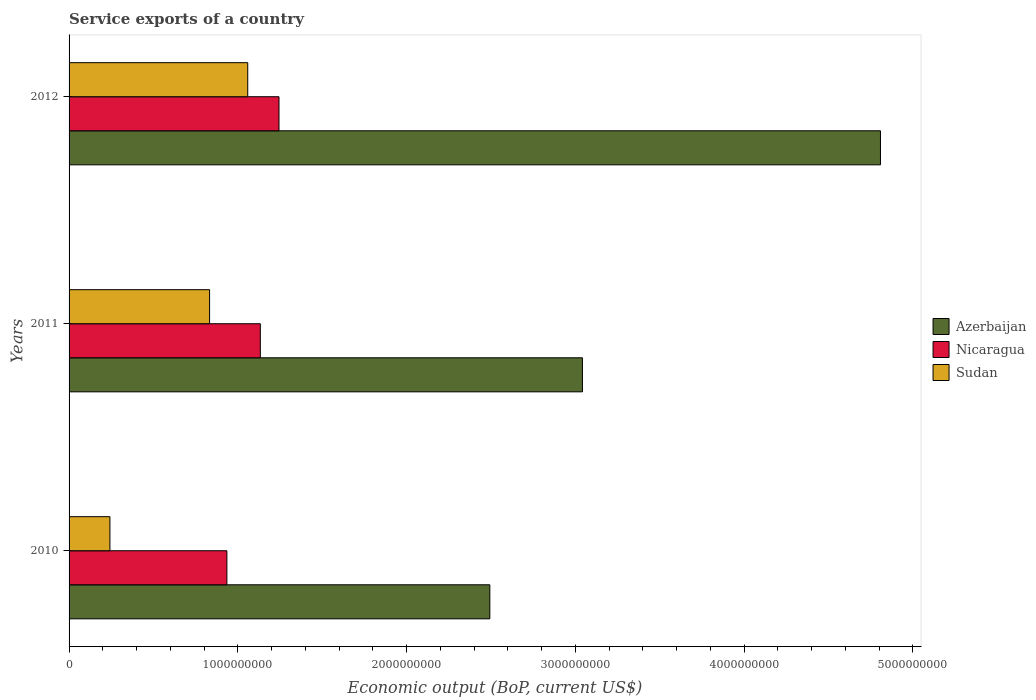How many groups of bars are there?
Provide a succinct answer. 3. Are the number of bars per tick equal to the number of legend labels?
Your response must be concise. Yes. Are the number of bars on each tick of the Y-axis equal?
Your answer should be very brief. Yes. How many bars are there on the 2nd tick from the top?
Give a very brief answer. 3. What is the service exports in Azerbaijan in 2012?
Provide a succinct answer. 4.81e+09. Across all years, what is the maximum service exports in Sudan?
Give a very brief answer. 1.06e+09. Across all years, what is the minimum service exports in Azerbaijan?
Ensure brevity in your answer.  2.49e+09. In which year was the service exports in Sudan maximum?
Your answer should be compact. 2012. In which year was the service exports in Azerbaijan minimum?
Offer a very short reply. 2010. What is the total service exports in Sudan in the graph?
Keep it short and to the point. 2.13e+09. What is the difference between the service exports in Nicaragua in 2010 and that in 2012?
Provide a short and direct response. -3.09e+08. What is the difference between the service exports in Azerbaijan in 2010 and the service exports in Nicaragua in 2012?
Your answer should be very brief. 1.25e+09. What is the average service exports in Azerbaijan per year?
Keep it short and to the point. 3.45e+09. In the year 2012, what is the difference between the service exports in Azerbaijan and service exports in Nicaragua?
Offer a terse response. 3.56e+09. What is the ratio of the service exports in Azerbaijan in 2011 to that in 2012?
Offer a terse response. 0.63. Is the difference between the service exports in Azerbaijan in 2011 and 2012 greater than the difference between the service exports in Nicaragua in 2011 and 2012?
Offer a terse response. No. What is the difference between the highest and the second highest service exports in Azerbaijan?
Make the answer very short. 1.77e+09. What is the difference between the highest and the lowest service exports in Sudan?
Offer a very short reply. 8.17e+08. In how many years, is the service exports in Sudan greater than the average service exports in Sudan taken over all years?
Your answer should be compact. 2. What does the 1st bar from the top in 2012 represents?
Make the answer very short. Sudan. What does the 2nd bar from the bottom in 2011 represents?
Ensure brevity in your answer.  Nicaragua. Are all the bars in the graph horizontal?
Make the answer very short. Yes. What is the difference between two consecutive major ticks on the X-axis?
Offer a terse response. 1.00e+09. Where does the legend appear in the graph?
Offer a very short reply. Center right. How are the legend labels stacked?
Offer a very short reply. Vertical. What is the title of the graph?
Your response must be concise. Service exports of a country. What is the label or title of the X-axis?
Your answer should be very brief. Economic output (BoP, current US$). What is the label or title of the Y-axis?
Keep it short and to the point. Years. What is the Economic output (BoP, current US$) in Azerbaijan in 2010?
Offer a terse response. 2.49e+09. What is the Economic output (BoP, current US$) of Nicaragua in 2010?
Provide a short and direct response. 9.35e+08. What is the Economic output (BoP, current US$) of Sudan in 2010?
Your response must be concise. 2.42e+08. What is the Economic output (BoP, current US$) in Azerbaijan in 2011?
Provide a succinct answer. 3.04e+09. What is the Economic output (BoP, current US$) in Nicaragua in 2011?
Offer a terse response. 1.13e+09. What is the Economic output (BoP, current US$) of Sudan in 2011?
Your answer should be compact. 8.33e+08. What is the Economic output (BoP, current US$) of Azerbaijan in 2012?
Offer a very short reply. 4.81e+09. What is the Economic output (BoP, current US$) of Nicaragua in 2012?
Keep it short and to the point. 1.24e+09. What is the Economic output (BoP, current US$) in Sudan in 2012?
Your answer should be compact. 1.06e+09. Across all years, what is the maximum Economic output (BoP, current US$) in Azerbaijan?
Offer a terse response. 4.81e+09. Across all years, what is the maximum Economic output (BoP, current US$) of Nicaragua?
Provide a short and direct response. 1.24e+09. Across all years, what is the maximum Economic output (BoP, current US$) of Sudan?
Your response must be concise. 1.06e+09. Across all years, what is the minimum Economic output (BoP, current US$) in Azerbaijan?
Ensure brevity in your answer.  2.49e+09. Across all years, what is the minimum Economic output (BoP, current US$) of Nicaragua?
Give a very brief answer. 9.35e+08. Across all years, what is the minimum Economic output (BoP, current US$) of Sudan?
Keep it short and to the point. 2.42e+08. What is the total Economic output (BoP, current US$) in Azerbaijan in the graph?
Make the answer very short. 1.03e+1. What is the total Economic output (BoP, current US$) of Nicaragua in the graph?
Offer a very short reply. 3.31e+09. What is the total Economic output (BoP, current US$) in Sudan in the graph?
Provide a succinct answer. 2.13e+09. What is the difference between the Economic output (BoP, current US$) of Azerbaijan in 2010 and that in 2011?
Provide a short and direct response. -5.49e+08. What is the difference between the Economic output (BoP, current US$) in Nicaragua in 2010 and that in 2011?
Give a very brief answer. -1.98e+08. What is the difference between the Economic output (BoP, current US$) of Sudan in 2010 and that in 2011?
Offer a terse response. -5.91e+08. What is the difference between the Economic output (BoP, current US$) of Azerbaijan in 2010 and that in 2012?
Ensure brevity in your answer.  -2.32e+09. What is the difference between the Economic output (BoP, current US$) of Nicaragua in 2010 and that in 2012?
Your response must be concise. -3.09e+08. What is the difference between the Economic output (BoP, current US$) in Sudan in 2010 and that in 2012?
Your answer should be very brief. -8.17e+08. What is the difference between the Economic output (BoP, current US$) of Azerbaijan in 2011 and that in 2012?
Provide a short and direct response. -1.77e+09. What is the difference between the Economic output (BoP, current US$) in Nicaragua in 2011 and that in 2012?
Offer a very short reply. -1.11e+08. What is the difference between the Economic output (BoP, current US$) of Sudan in 2011 and that in 2012?
Offer a terse response. -2.26e+08. What is the difference between the Economic output (BoP, current US$) of Azerbaijan in 2010 and the Economic output (BoP, current US$) of Nicaragua in 2011?
Give a very brief answer. 1.36e+09. What is the difference between the Economic output (BoP, current US$) in Azerbaijan in 2010 and the Economic output (BoP, current US$) in Sudan in 2011?
Your response must be concise. 1.66e+09. What is the difference between the Economic output (BoP, current US$) in Nicaragua in 2010 and the Economic output (BoP, current US$) in Sudan in 2011?
Provide a succinct answer. 1.03e+08. What is the difference between the Economic output (BoP, current US$) in Azerbaijan in 2010 and the Economic output (BoP, current US$) in Nicaragua in 2012?
Offer a very short reply. 1.25e+09. What is the difference between the Economic output (BoP, current US$) of Azerbaijan in 2010 and the Economic output (BoP, current US$) of Sudan in 2012?
Your answer should be very brief. 1.43e+09. What is the difference between the Economic output (BoP, current US$) in Nicaragua in 2010 and the Economic output (BoP, current US$) in Sudan in 2012?
Make the answer very short. -1.24e+08. What is the difference between the Economic output (BoP, current US$) in Azerbaijan in 2011 and the Economic output (BoP, current US$) in Nicaragua in 2012?
Make the answer very short. 1.80e+09. What is the difference between the Economic output (BoP, current US$) in Azerbaijan in 2011 and the Economic output (BoP, current US$) in Sudan in 2012?
Keep it short and to the point. 1.98e+09. What is the difference between the Economic output (BoP, current US$) of Nicaragua in 2011 and the Economic output (BoP, current US$) of Sudan in 2012?
Your answer should be very brief. 7.47e+07. What is the average Economic output (BoP, current US$) in Azerbaijan per year?
Give a very brief answer. 3.45e+09. What is the average Economic output (BoP, current US$) in Nicaragua per year?
Offer a terse response. 1.10e+09. What is the average Economic output (BoP, current US$) in Sudan per year?
Make the answer very short. 7.11e+08. In the year 2010, what is the difference between the Economic output (BoP, current US$) of Azerbaijan and Economic output (BoP, current US$) of Nicaragua?
Your answer should be very brief. 1.56e+09. In the year 2010, what is the difference between the Economic output (BoP, current US$) of Azerbaijan and Economic output (BoP, current US$) of Sudan?
Ensure brevity in your answer.  2.25e+09. In the year 2010, what is the difference between the Economic output (BoP, current US$) in Nicaragua and Economic output (BoP, current US$) in Sudan?
Provide a succinct answer. 6.93e+08. In the year 2011, what is the difference between the Economic output (BoP, current US$) of Azerbaijan and Economic output (BoP, current US$) of Nicaragua?
Provide a short and direct response. 1.91e+09. In the year 2011, what is the difference between the Economic output (BoP, current US$) in Azerbaijan and Economic output (BoP, current US$) in Sudan?
Give a very brief answer. 2.21e+09. In the year 2011, what is the difference between the Economic output (BoP, current US$) in Nicaragua and Economic output (BoP, current US$) in Sudan?
Provide a succinct answer. 3.01e+08. In the year 2012, what is the difference between the Economic output (BoP, current US$) of Azerbaijan and Economic output (BoP, current US$) of Nicaragua?
Your response must be concise. 3.56e+09. In the year 2012, what is the difference between the Economic output (BoP, current US$) in Azerbaijan and Economic output (BoP, current US$) in Sudan?
Provide a short and direct response. 3.75e+09. In the year 2012, what is the difference between the Economic output (BoP, current US$) in Nicaragua and Economic output (BoP, current US$) in Sudan?
Give a very brief answer. 1.85e+08. What is the ratio of the Economic output (BoP, current US$) in Azerbaijan in 2010 to that in 2011?
Give a very brief answer. 0.82. What is the ratio of the Economic output (BoP, current US$) in Nicaragua in 2010 to that in 2011?
Your answer should be compact. 0.83. What is the ratio of the Economic output (BoP, current US$) in Sudan in 2010 to that in 2011?
Make the answer very short. 0.29. What is the ratio of the Economic output (BoP, current US$) of Azerbaijan in 2010 to that in 2012?
Offer a terse response. 0.52. What is the ratio of the Economic output (BoP, current US$) of Nicaragua in 2010 to that in 2012?
Ensure brevity in your answer.  0.75. What is the ratio of the Economic output (BoP, current US$) of Sudan in 2010 to that in 2012?
Provide a succinct answer. 0.23. What is the ratio of the Economic output (BoP, current US$) of Azerbaijan in 2011 to that in 2012?
Offer a terse response. 0.63. What is the ratio of the Economic output (BoP, current US$) in Nicaragua in 2011 to that in 2012?
Ensure brevity in your answer.  0.91. What is the ratio of the Economic output (BoP, current US$) in Sudan in 2011 to that in 2012?
Your answer should be very brief. 0.79. What is the difference between the highest and the second highest Economic output (BoP, current US$) in Azerbaijan?
Provide a succinct answer. 1.77e+09. What is the difference between the highest and the second highest Economic output (BoP, current US$) of Nicaragua?
Make the answer very short. 1.11e+08. What is the difference between the highest and the second highest Economic output (BoP, current US$) in Sudan?
Your answer should be very brief. 2.26e+08. What is the difference between the highest and the lowest Economic output (BoP, current US$) in Azerbaijan?
Make the answer very short. 2.32e+09. What is the difference between the highest and the lowest Economic output (BoP, current US$) in Nicaragua?
Your response must be concise. 3.09e+08. What is the difference between the highest and the lowest Economic output (BoP, current US$) of Sudan?
Offer a terse response. 8.17e+08. 